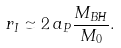Convert formula to latex. <formula><loc_0><loc_0><loc_500><loc_500>r _ { I } \simeq 2 \, a _ { P } \frac { M _ { B H } } { M _ { 0 } } .</formula> 